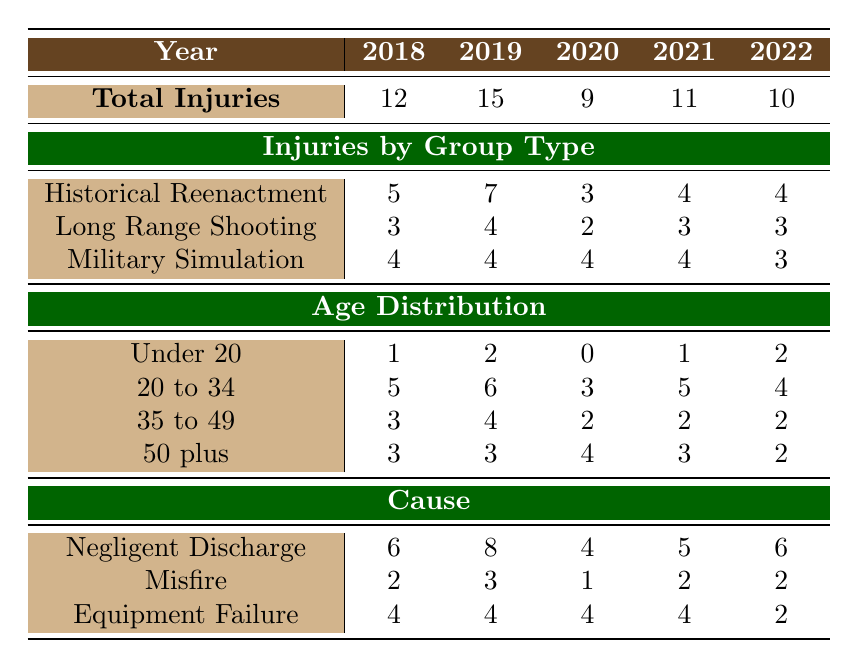What was the total number of firearm injuries in 2020? The table lists total injuries for each year. In the row corresponding to the year 2020, the value under "Total Injuries" is 9.
Answer: 9 Which group type had the highest number of injuries in 2019? By looking at the "Injuries by Group Type" row for 2019, we see that "Historical Reenactment" had 7 injuries, which is the highest compared to other group types.
Answer: Historical Reenactment What percentage of total injuries in 2021 were due to negligent discharge? The total injuries in 2021 are 11, and negligent discharge caused 5 injuries. To find the percentage, divide 5 by 11 and multiply by 100, which gives approximately 45.45%.
Answer: 45.45% Did the number of "Under 20" age group injuries increase from 2018 to 2022? From the table, the number of injuries under the age of 20 in 2018 was 1 and in 2022 it was 2, indicating an increase.
Answer: Yes What is the average number of injuries for "Military Simulation" across all years? For "Military Simulation," the injuries are 4, 4, 4, 4, and 3 over the years listed. Summing these gives 19, and dividing by the number of years (5) results in an average of 3.8.
Answer: 3.8 How many injuries were caused by equipment failure in 2018 compared to 2020? In the table, equipment failure caused 4 injuries in 2018 and 4 injuries in 2020. Thus, they are equal.
Answer: They are equal What was the total number of injuries reported for the "Long Range Shooting" group from 2018 to 2022? To find the total injuries for "Long Range Shooting," we add the values: 3 (2018) + 4 (2019) + 2 (2020) + 3 (2021) + 3 (2022) = 15.
Answer: 15 In which year did the overall total injuries drop to the lowest? The table shows the total injuries for each year, with 9 injuries in 2020 being the lowest value.
Answer: 2020 What caused more injuries in 2022 than in 2021: negligent discharge or equipment failure? In 2022, negligent discharge caused 6 injuries, while equipment failure caused only 2 injuries in that year, whereas in 2021, negligent discharge caused 5 injuries, and equipment failure caused 4. Hence, negligent discharge did increase.
Answer: Negligent discharge 